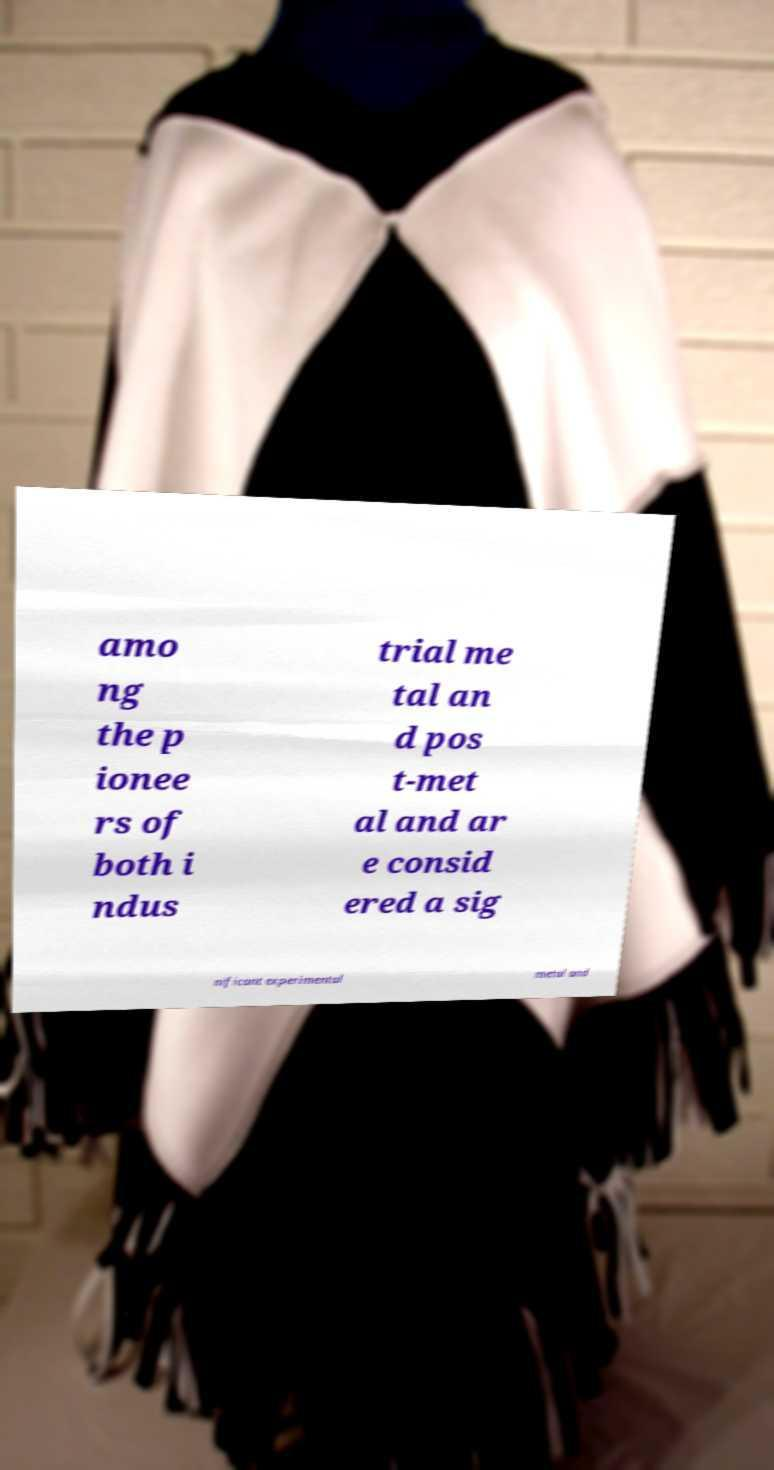Could you extract and type out the text from this image? amo ng the p ionee rs of both i ndus trial me tal an d pos t-met al and ar e consid ered a sig nificant experimental metal and 